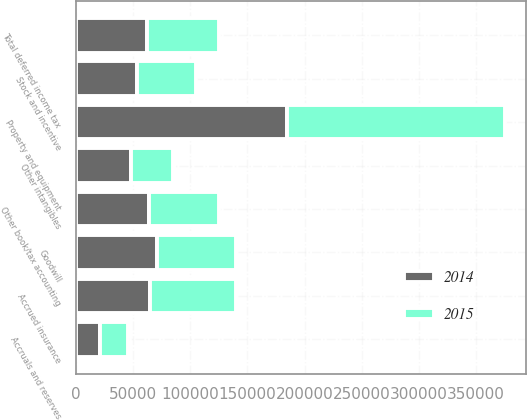Convert chart. <chart><loc_0><loc_0><loc_500><loc_500><stacked_bar_chart><ecel><fcel>Property and equipment<fcel>Goodwill<fcel>Other intangibles<fcel>Other book/tax accounting<fcel>Total deferred income tax<fcel>Accruals and reserves<fcel>Accrued insurance<fcel>Stock and incentive<nl><fcel>2015<fcel>189793<fcel>69059<fcel>36565<fcel>61095<fcel>62457<fcel>25070<fcel>75591<fcel>52009<nl><fcel>2014<fcel>185007<fcel>70832<fcel>48344<fcel>63819<fcel>62457<fcel>20835<fcel>64745<fcel>53155<nl></chart> 